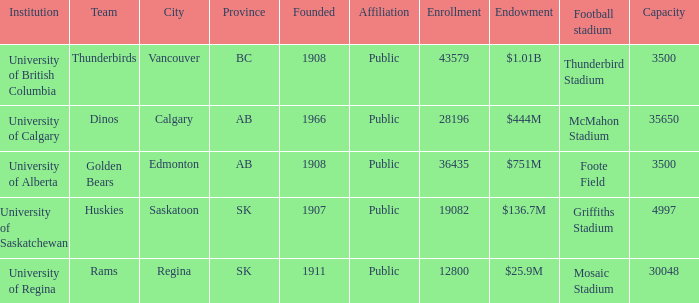Which institution has an endowment of $25.9m? University of Regina. 